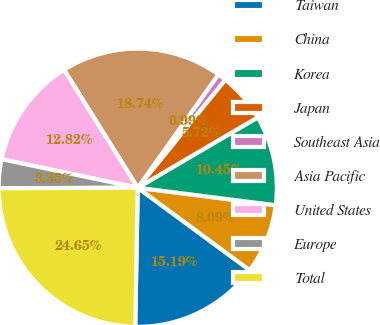<chart> <loc_0><loc_0><loc_500><loc_500><pie_chart><fcel>Taiwan<fcel>China<fcel>Korea<fcel>Japan<fcel>Southeast Asia<fcel>Asia Pacific<fcel>United States<fcel>Europe<fcel>Total<nl><fcel>15.19%<fcel>8.09%<fcel>10.45%<fcel>5.72%<fcel>0.99%<fcel>18.74%<fcel>12.82%<fcel>3.35%<fcel>24.65%<nl></chart> 